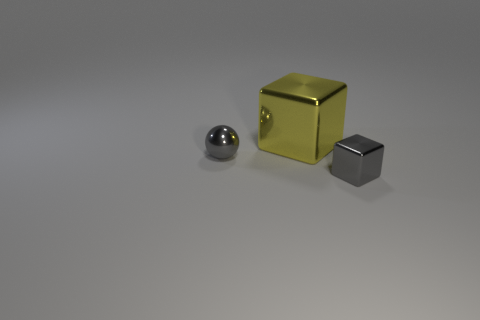There is another object that is the same shape as the large yellow object; what is its size?
Provide a succinct answer. Small. How big is the yellow cube?
Provide a short and direct response. Large. Are there more objects in front of the yellow metallic block than gray metallic blocks?
Your answer should be very brief. Yes. There is a shiny cube in front of the yellow block; is it the same color as the small shiny object that is on the left side of the big yellow object?
Keep it short and to the point. Yes. Is the number of tiny cyan matte objects greater than the number of tiny gray shiny things?
Your response must be concise. No. Is there anything else of the same color as the tiny metallic sphere?
Provide a short and direct response. Yes. There is a yellow thing that is the same material as the small ball; what size is it?
Make the answer very short. Large. What is the large thing made of?
Offer a very short reply. Metal. How many gray shiny cubes are the same size as the yellow metallic cube?
Offer a very short reply. 0. The metal thing that is the same color as the tiny cube is what shape?
Give a very brief answer. Sphere. 